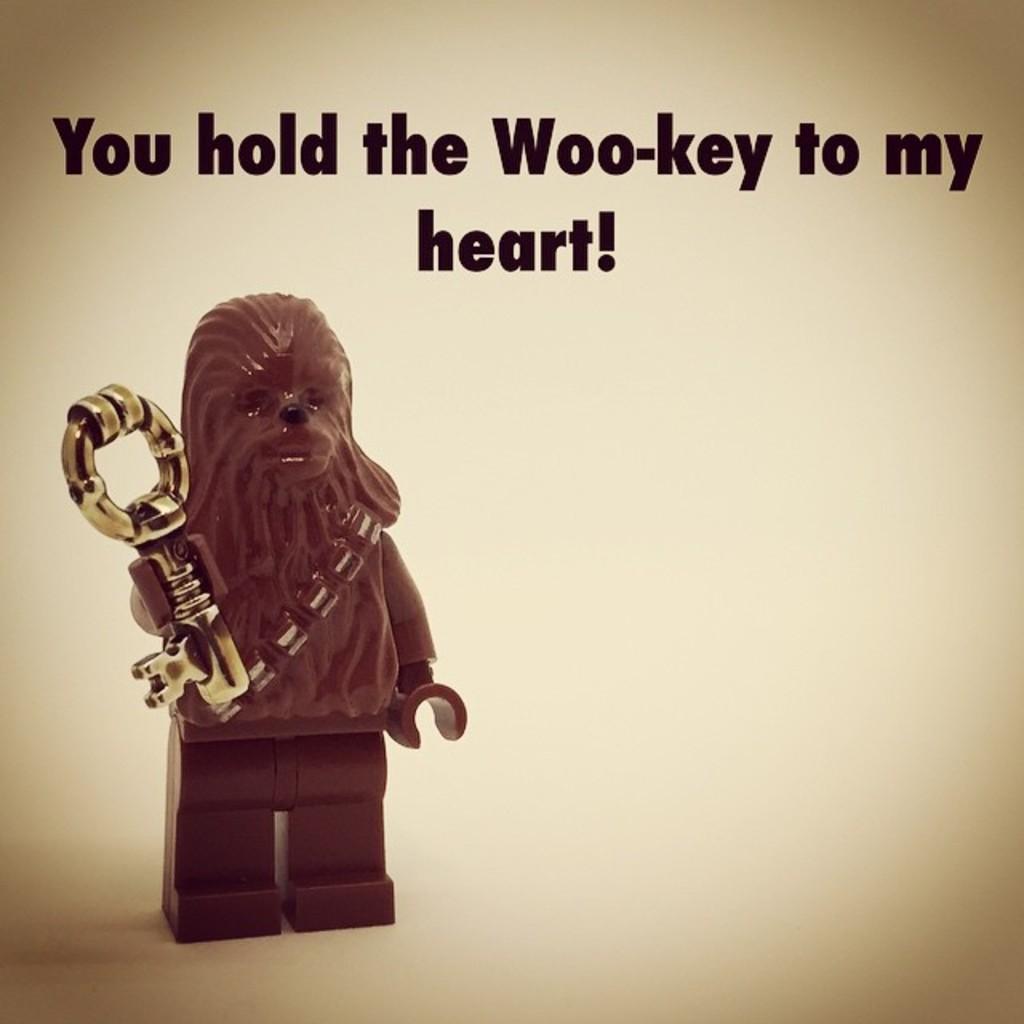In one or two sentences, can you explain what this image depicts? In this image on the left side we can see a toy holding a key in the hand on a platform. At the top we can see texts written on the image. 